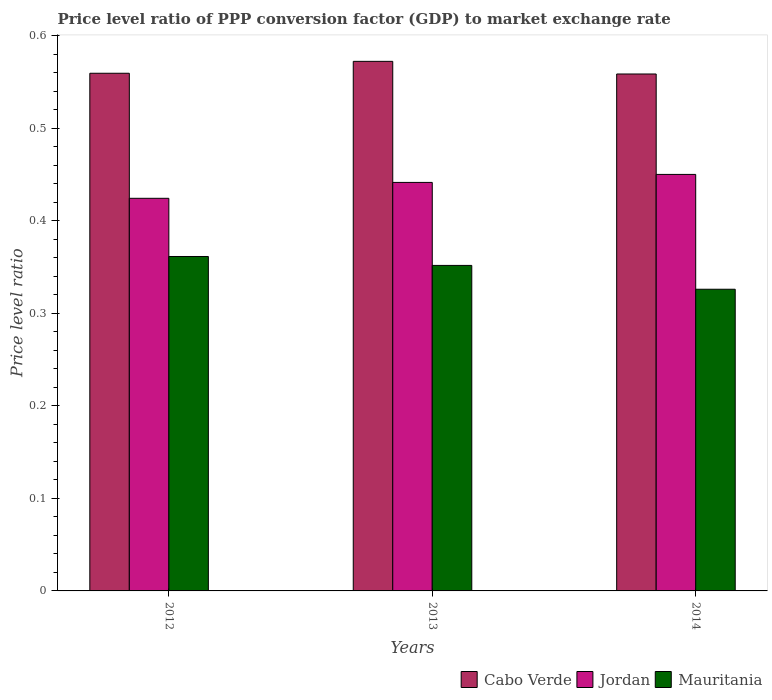How many groups of bars are there?
Your response must be concise. 3. How many bars are there on the 1st tick from the left?
Offer a terse response. 3. In how many cases, is the number of bars for a given year not equal to the number of legend labels?
Make the answer very short. 0. What is the price level ratio in Cabo Verde in 2012?
Your response must be concise. 0.56. Across all years, what is the maximum price level ratio in Mauritania?
Provide a succinct answer. 0.36. Across all years, what is the minimum price level ratio in Cabo Verde?
Provide a succinct answer. 0.56. What is the total price level ratio in Jordan in the graph?
Provide a short and direct response. 1.32. What is the difference between the price level ratio in Jordan in 2012 and that in 2013?
Provide a short and direct response. -0.02. What is the difference between the price level ratio in Cabo Verde in 2012 and the price level ratio in Jordan in 2013?
Keep it short and to the point. 0.12. What is the average price level ratio in Cabo Verde per year?
Keep it short and to the point. 0.56. In the year 2012, what is the difference between the price level ratio in Mauritania and price level ratio in Jordan?
Provide a short and direct response. -0.06. In how many years, is the price level ratio in Mauritania greater than 0.32000000000000006?
Offer a very short reply. 3. What is the ratio of the price level ratio in Mauritania in 2012 to that in 2013?
Your response must be concise. 1.03. Is the difference between the price level ratio in Mauritania in 2013 and 2014 greater than the difference between the price level ratio in Jordan in 2013 and 2014?
Your answer should be very brief. Yes. What is the difference between the highest and the second highest price level ratio in Mauritania?
Make the answer very short. 0.01. What is the difference between the highest and the lowest price level ratio in Jordan?
Keep it short and to the point. 0.03. Is the sum of the price level ratio in Cabo Verde in 2013 and 2014 greater than the maximum price level ratio in Jordan across all years?
Your answer should be compact. Yes. What does the 2nd bar from the left in 2013 represents?
Your answer should be compact. Jordan. What does the 1st bar from the right in 2013 represents?
Make the answer very short. Mauritania. How many bars are there?
Your response must be concise. 9. How many years are there in the graph?
Ensure brevity in your answer.  3. What is the difference between two consecutive major ticks on the Y-axis?
Keep it short and to the point. 0.1. Are the values on the major ticks of Y-axis written in scientific E-notation?
Give a very brief answer. No. How are the legend labels stacked?
Offer a terse response. Horizontal. What is the title of the graph?
Provide a succinct answer. Price level ratio of PPP conversion factor (GDP) to market exchange rate. What is the label or title of the X-axis?
Your answer should be very brief. Years. What is the label or title of the Y-axis?
Offer a very short reply. Price level ratio. What is the Price level ratio in Cabo Verde in 2012?
Provide a short and direct response. 0.56. What is the Price level ratio in Jordan in 2012?
Your answer should be very brief. 0.42. What is the Price level ratio of Mauritania in 2012?
Give a very brief answer. 0.36. What is the Price level ratio of Cabo Verde in 2013?
Your answer should be compact. 0.57. What is the Price level ratio in Jordan in 2013?
Ensure brevity in your answer.  0.44. What is the Price level ratio in Mauritania in 2013?
Provide a short and direct response. 0.35. What is the Price level ratio in Cabo Verde in 2014?
Provide a succinct answer. 0.56. What is the Price level ratio of Jordan in 2014?
Offer a terse response. 0.45. What is the Price level ratio of Mauritania in 2014?
Your answer should be compact. 0.33. Across all years, what is the maximum Price level ratio of Cabo Verde?
Give a very brief answer. 0.57. Across all years, what is the maximum Price level ratio of Jordan?
Keep it short and to the point. 0.45. Across all years, what is the maximum Price level ratio of Mauritania?
Make the answer very short. 0.36. Across all years, what is the minimum Price level ratio of Cabo Verde?
Make the answer very short. 0.56. Across all years, what is the minimum Price level ratio in Jordan?
Offer a terse response. 0.42. Across all years, what is the minimum Price level ratio in Mauritania?
Your answer should be very brief. 0.33. What is the total Price level ratio of Cabo Verde in the graph?
Give a very brief answer. 1.69. What is the total Price level ratio of Jordan in the graph?
Make the answer very short. 1.32. What is the total Price level ratio in Mauritania in the graph?
Offer a very short reply. 1.04. What is the difference between the Price level ratio of Cabo Verde in 2012 and that in 2013?
Make the answer very short. -0.01. What is the difference between the Price level ratio in Jordan in 2012 and that in 2013?
Offer a very short reply. -0.02. What is the difference between the Price level ratio in Mauritania in 2012 and that in 2013?
Offer a very short reply. 0.01. What is the difference between the Price level ratio of Cabo Verde in 2012 and that in 2014?
Make the answer very short. 0. What is the difference between the Price level ratio in Jordan in 2012 and that in 2014?
Make the answer very short. -0.03. What is the difference between the Price level ratio of Mauritania in 2012 and that in 2014?
Your response must be concise. 0.04. What is the difference between the Price level ratio of Cabo Verde in 2013 and that in 2014?
Provide a succinct answer. 0.01. What is the difference between the Price level ratio of Jordan in 2013 and that in 2014?
Make the answer very short. -0.01. What is the difference between the Price level ratio in Mauritania in 2013 and that in 2014?
Offer a terse response. 0.03. What is the difference between the Price level ratio in Cabo Verde in 2012 and the Price level ratio in Jordan in 2013?
Make the answer very short. 0.12. What is the difference between the Price level ratio in Cabo Verde in 2012 and the Price level ratio in Mauritania in 2013?
Ensure brevity in your answer.  0.21. What is the difference between the Price level ratio in Jordan in 2012 and the Price level ratio in Mauritania in 2013?
Give a very brief answer. 0.07. What is the difference between the Price level ratio in Cabo Verde in 2012 and the Price level ratio in Jordan in 2014?
Your answer should be very brief. 0.11. What is the difference between the Price level ratio in Cabo Verde in 2012 and the Price level ratio in Mauritania in 2014?
Provide a succinct answer. 0.23. What is the difference between the Price level ratio in Jordan in 2012 and the Price level ratio in Mauritania in 2014?
Provide a short and direct response. 0.1. What is the difference between the Price level ratio of Cabo Verde in 2013 and the Price level ratio of Jordan in 2014?
Ensure brevity in your answer.  0.12. What is the difference between the Price level ratio of Cabo Verde in 2013 and the Price level ratio of Mauritania in 2014?
Ensure brevity in your answer.  0.25. What is the difference between the Price level ratio of Jordan in 2013 and the Price level ratio of Mauritania in 2014?
Your response must be concise. 0.12. What is the average Price level ratio of Cabo Verde per year?
Offer a terse response. 0.56. What is the average Price level ratio in Jordan per year?
Your answer should be compact. 0.44. What is the average Price level ratio in Mauritania per year?
Offer a terse response. 0.35. In the year 2012, what is the difference between the Price level ratio of Cabo Verde and Price level ratio of Jordan?
Offer a very short reply. 0.14. In the year 2012, what is the difference between the Price level ratio in Cabo Verde and Price level ratio in Mauritania?
Offer a terse response. 0.2. In the year 2012, what is the difference between the Price level ratio of Jordan and Price level ratio of Mauritania?
Keep it short and to the point. 0.06. In the year 2013, what is the difference between the Price level ratio of Cabo Verde and Price level ratio of Jordan?
Offer a terse response. 0.13. In the year 2013, what is the difference between the Price level ratio of Cabo Verde and Price level ratio of Mauritania?
Offer a terse response. 0.22. In the year 2013, what is the difference between the Price level ratio in Jordan and Price level ratio in Mauritania?
Your answer should be compact. 0.09. In the year 2014, what is the difference between the Price level ratio of Cabo Verde and Price level ratio of Jordan?
Your response must be concise. 0.11. In the year 2014, what is the difference between the Price level ratio of Cabo Verde and Price level ratio of Mauritania?
Provide a short and direct response. 0.23. In the year 2014, what is the difference between the Price level ratio in Jordan and Price level ratio in Mauritania?
Offer a terse response. 0.12. What is the ratio of the Price level ratio of Cabo Verde in 2012 to that in 2013?
Provide a short and direct response. 0.98. What is the ratio of the Price level ratio in Jordan in 2012 to that in 2013?
Keep it short and to the point. 0.96. What is the ratio of the Price level ratio in Mauritania in 2012 to that in 2013?
Provide a succinct answer. 1.03. What is the ratio of the Price level ratio of Jordan in 2012 to that in 2014?
Your answer should be very brief. 0.94. What is the ratio of the Price level ratio of Mauritania in 2012 to that in 2014?
Provide a short and direct response. 1.11. What is the ratio of the Price level ratio in Cabo Verde in 2013 to that in 2014?
Your answer should be compact. 1.02. What is the ratio of the Price level ratio of Jordan in 2013 to that in 2014?
Give a very brief answer. 0.98. What is the ratio of the Price level ratio in Mauritania in 2013 to that in 2014?
Make the answer very short. 1.08. What is the difference between the highest and the second highest Price level ratio of Cabo Verde?
Your response must be concise. 0.01. What is the difference between the highest and the second highest Price level ratio of Jordan?
Keep it short and to the point. 0.01. What is the difference between the highest and the second highest Price level ratio in Mauritania?
Make the answer very short. 0.01. What is the difference between the highest and the lowest Price level ratio in Cabo Verde?
Your response must be concise. 0.01. What is the difference between the highest and the lowest Price level ratio of Jordan?
Offer a terse response. 0.03. What is the difference between the highest and the lowest Price level ratio in Mauritania?
Make the answer very short. 0.04. 